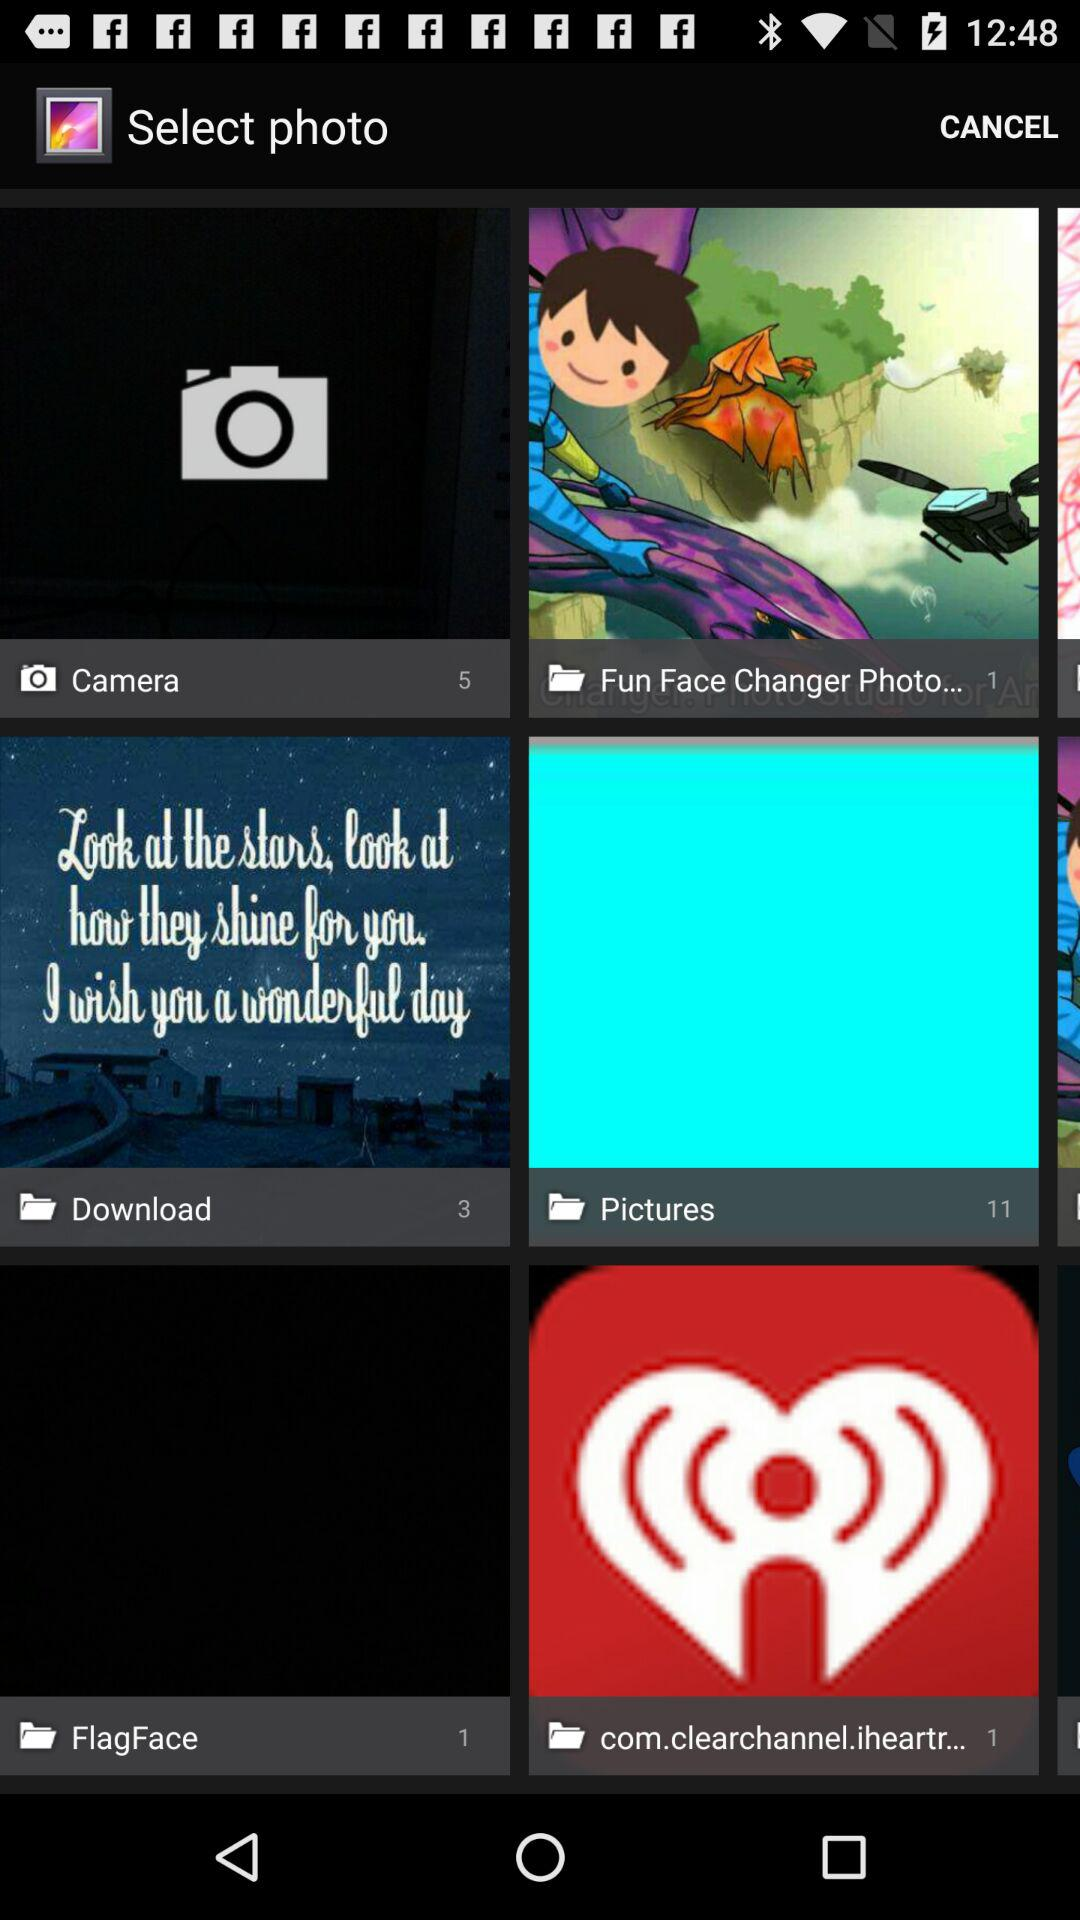What is the number of images in the "FlagFace" folder? The number of images in the "FlagFace" folder is 1. 